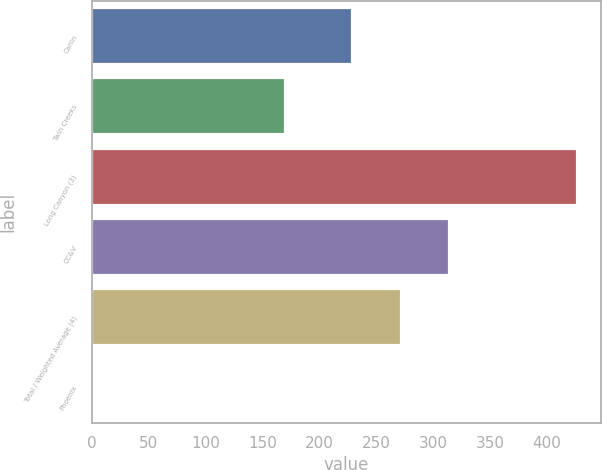<chart> <loc_0><loc_0><loc_500><loc_500><bar_chart><fcel>Carlin<fcel>Twin Creeks<fcel>Long Canyon (3)<fcel>CC&V<fcel>Total / Weighted Average (4)<fcel>Phoenix<nl><fcel>229<fcel>170<fcel>426<fcel>314.1<fcel>271.55<fcel>0.46<nl></chart> 